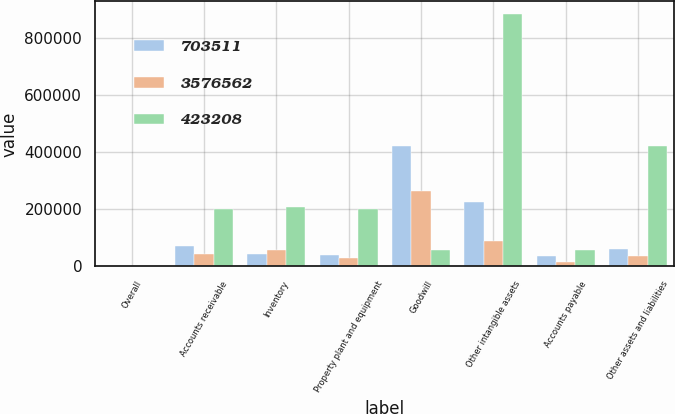Convert chart to OTSL. <chart><loc_0><loc_0><loc_500><loc_500><stacked_bar_chart><ecel><fcel>Overall<fcel>Accounts receivable<fcel>Inventory<fcel>Property plant and equipment<fcel>Goodwill<fcel>Other intangible assets<fcel>Accounts payable<fcel>Other assets and liabilities<nl><fcel>703511<fcel>2009<fcel>70578<fcel>42775<fcel>39034<fcel>422951<fcel>224713<fcel>35064<fcel>62101<nl><fcel>3.57656e+06<fcel>2008<fcel>43788<fcel>56370<fcel>30139<fcel>264557<fcel>88668<fcel>16112<fcel>35921<nl><fcel>423208<fcel>2007<fcel>200199<fcel>207336<fcel>202203<fcel>57617<fcel>884263<fcel>57617<fcel>420418<nl></chart> 